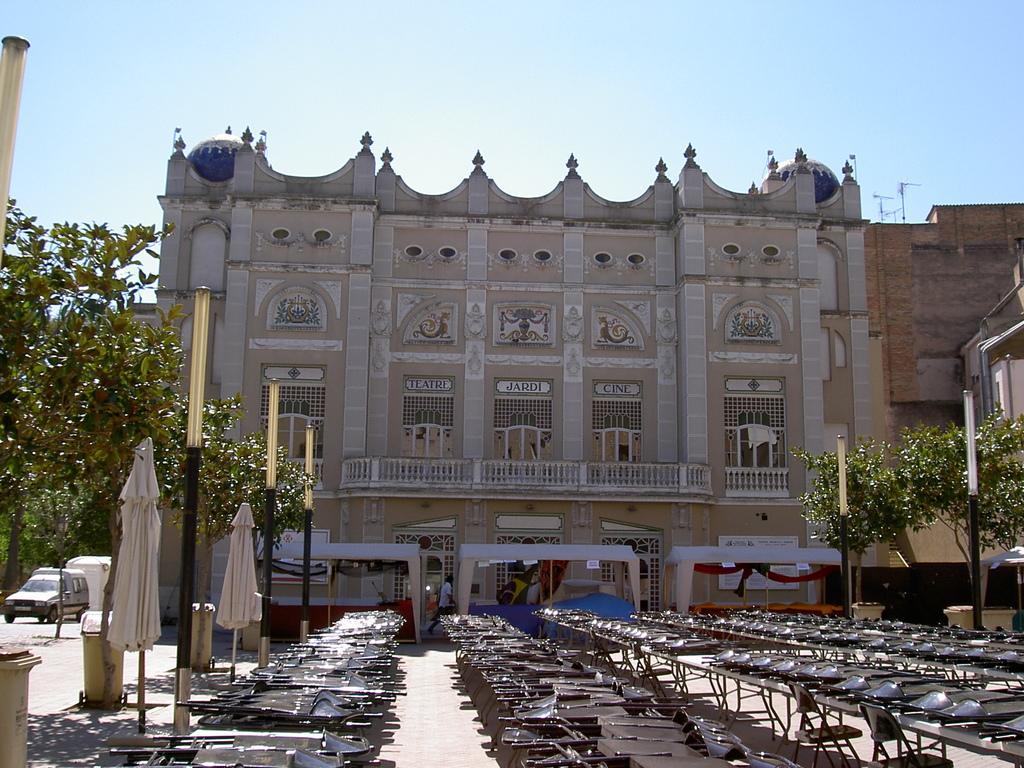How would you summarize this image in a sentence or two? This is an outside view. At the bottom of this image I can see few tables on which many chairs are placed. On the left side there are some poles, two dustbins and also I can see a car on the road. In the background there is a building. On both sides of this building I can see the trees. On the top of the image I can see the sky. 